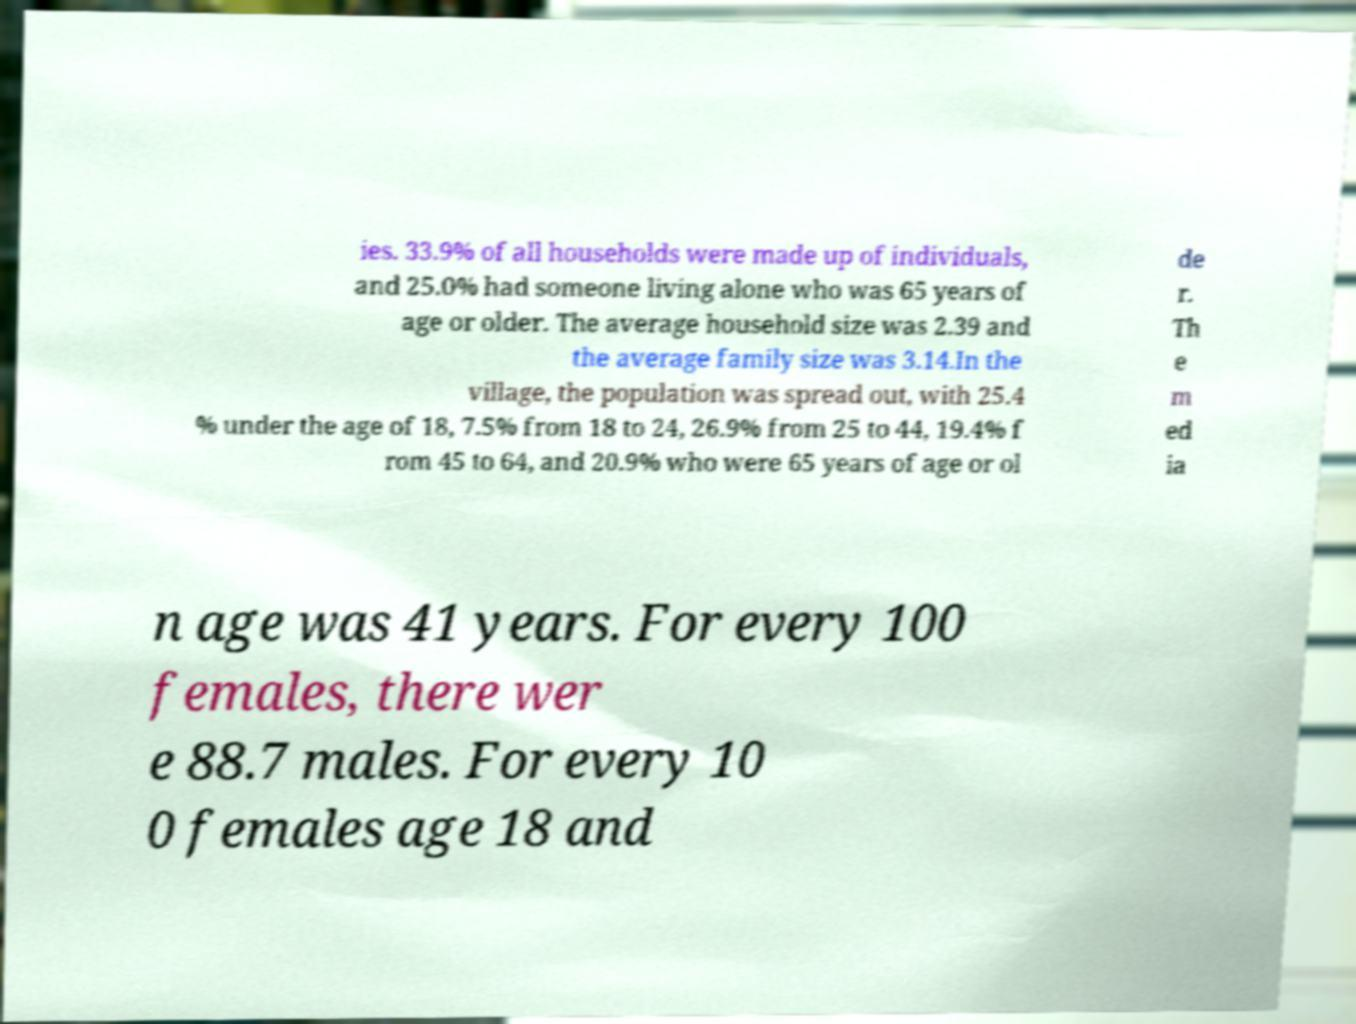Please identify and transcribe the text found in this image. ies. 33.9% of all households were made up of individuals, and 25.0% had someone living alone who was 65 years of age or older. The average household size was 2.39 and the average family size was 3.14.In the village, the population was spread out, with 25.4 % under the age of 18, 7.5% from 18 to 24, 26.9% from 25 to 44, 19.4% f rom 45 to 64, and 20.9% who were 65 years of age or ol de r. Th e m ed ia n age was 41 years. For every 100 females, there wer e 88.7 males. For every 10 0 females age 18 and 